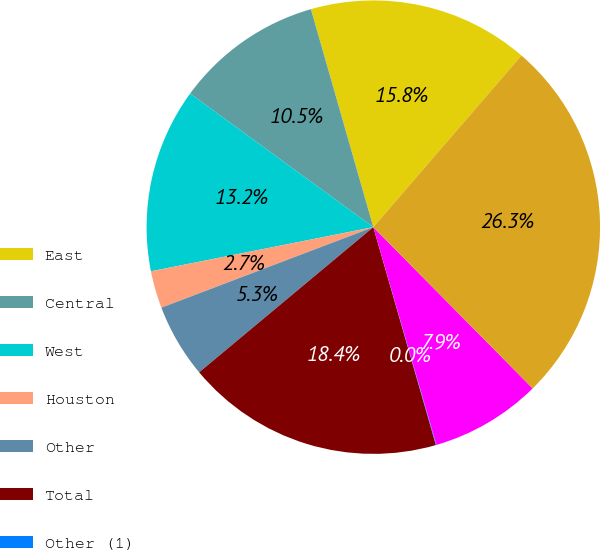Convert chart. <chart><loc_0><loc_0><loc_500><loc_500><pie_chart><fcel>East<fcel>Central<fcel>West<fcel>Houston<fcel>Other<fcel>Total<fcel>Other (1)<fcel>West (2)<fcel>Total valuation adjustments<nl><fcel>15.77%<fcel>10.53%<fcel>13.15%<fcel>2.66%<fcel>5.28%<fcel>18.39%<fcel>0.04%<fcel>7.91%<fcel>26.26%<nl></chart> 